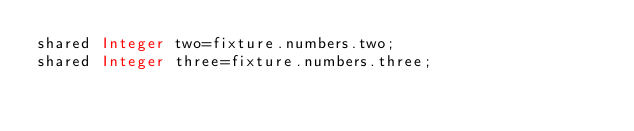<code> <loc_0><loc_0><loc_500><loc_500><_Ceylon_>shared Integer two=fixture.numbers.two;
shared Integer three=fixture.numbers.three;
</code> 